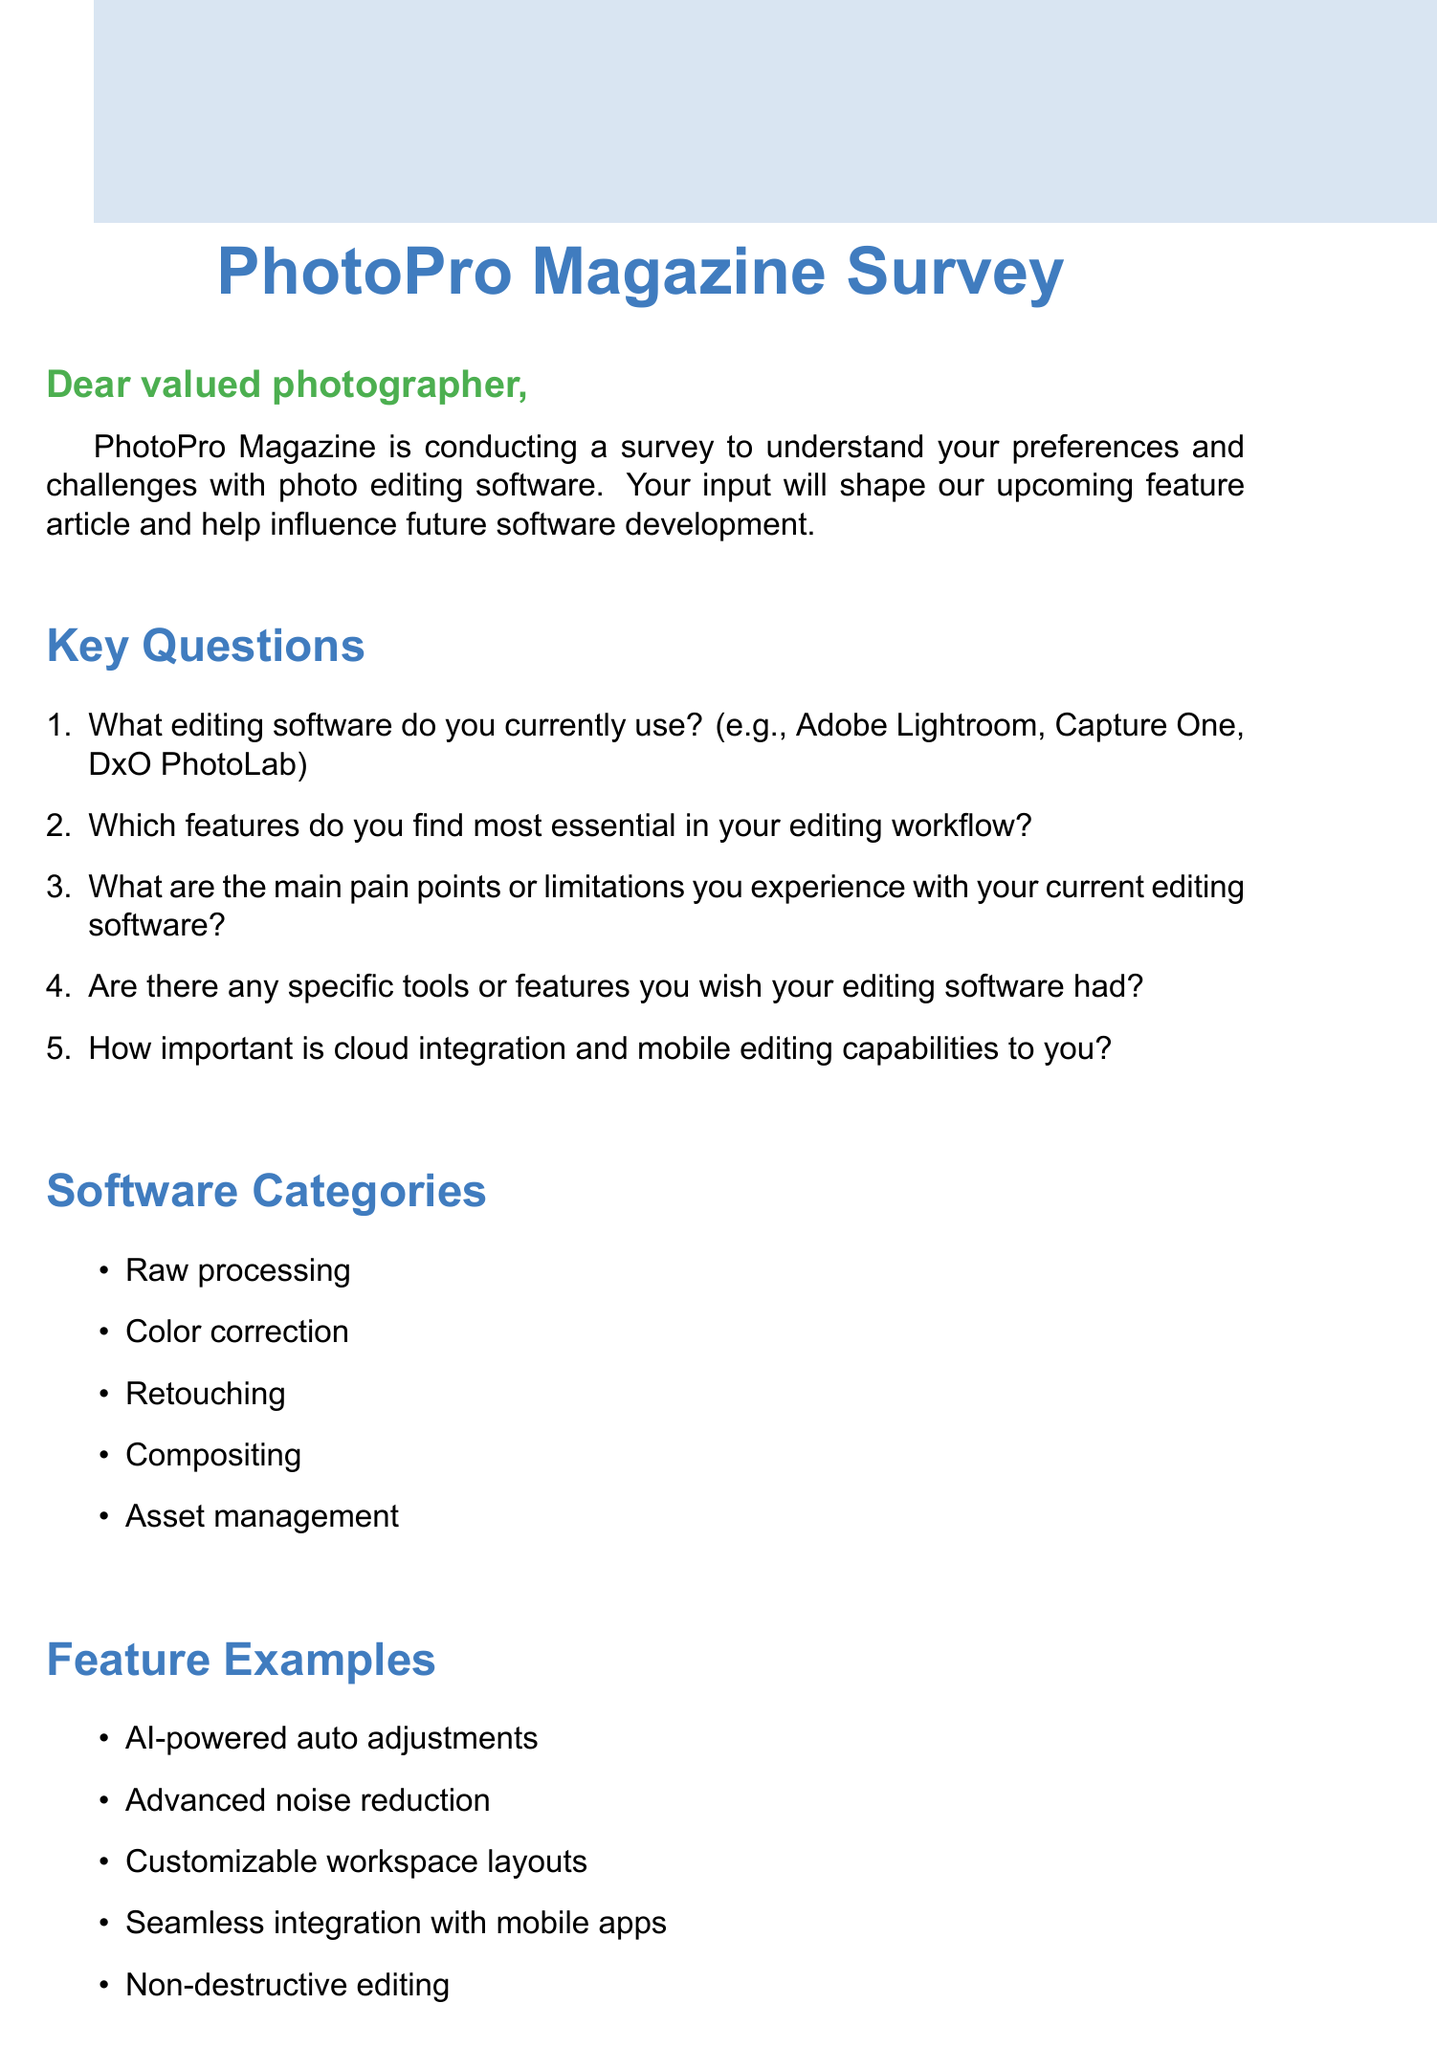What is the purpose of the survey? The survey aims to understand preferences and challenges with photo editing software.
Answer: To understand preferences and challenges with photo editing software What is the main incentive for participating in the survey? Participants will be entered into a draw to win a one-year subscription to editing software of their choice.
Answer: One-year subscription to editing software of choice Which editing software examples are provided in the document? The document mentions Adobe Lightroom, Capture One, and DxO PhotoLab as examples.
Answer: Adobe Lightroom, Capture One, DxO PhotoLab What are the common pain points listed in the document? The document lists slow performance, steep learning curve, limited plugin support, inconsistent results, and lack of specific tools.
Answer: Slow performance, steep learning curve, limited plugin support, inconsistent results, lack of specific tools How many key questions are included in the survey introduction? The document lists five key questions that are part of the survey.
Answer: Five key questions Which feature example involves AI technology? The document mentions "AI-powered auto adjustments" as a feature example.
Answer: AI-powered auto adjustments What type of document is this? The document is a request for feedback in the form of a survey.
Answer: A survey request How are the questions formatted in the survey? The key questions are formatted as an enumerated list.
Answer: An enumerated list 